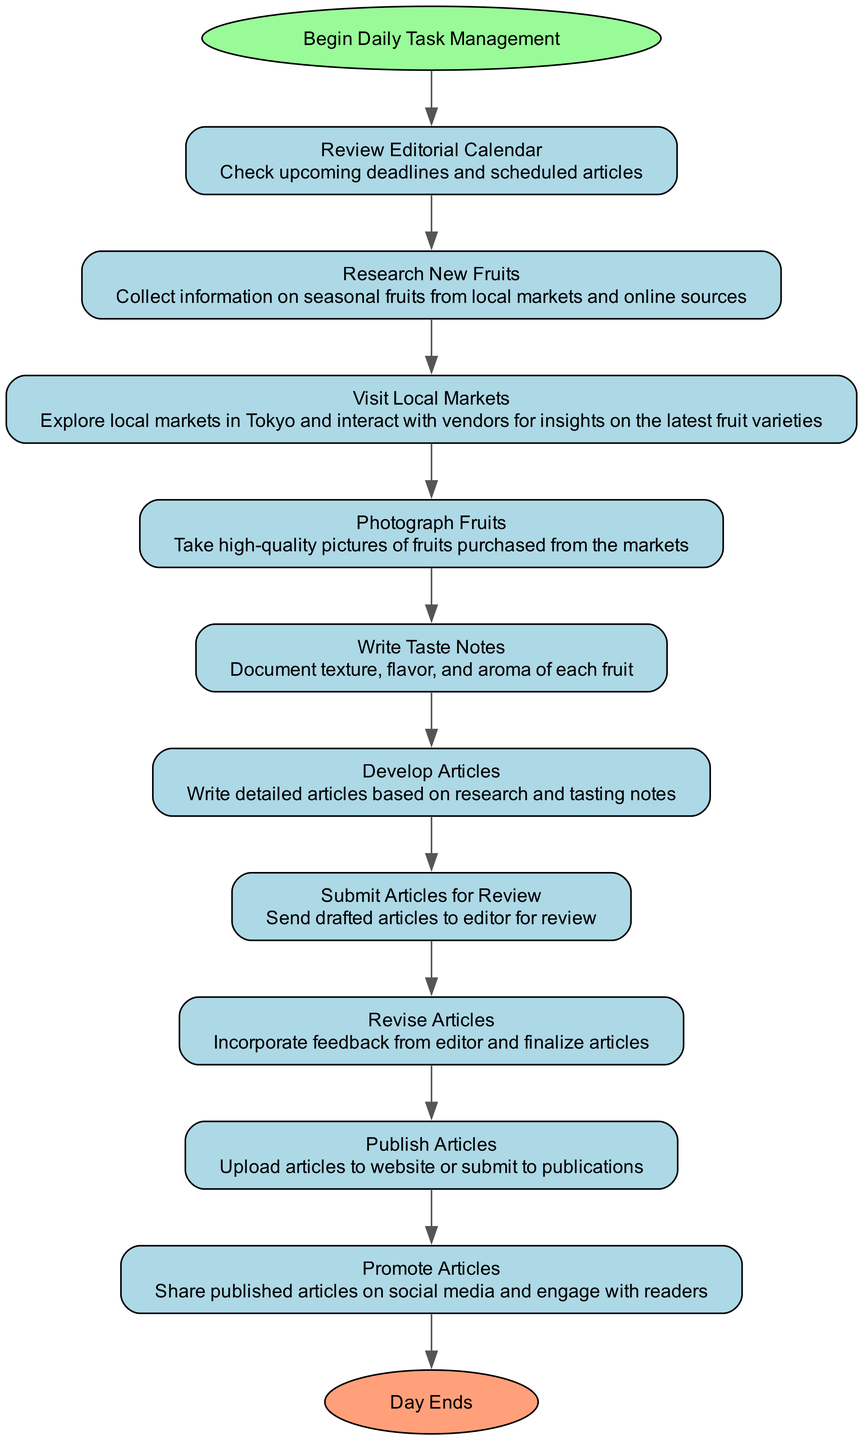What is the first task in the daily management? The first task is found after the "Start" node, which leads to "Review Editorial Calendar". This is the initial action to be taken.
Answer: Review Editorial Calendar How many tasks are listed in the diagram? By counting each task node from "Research New Fruits" to "Promote Articles", we find there are a total of 10 tasks, including "Review Editorial Calendar" and "Promote Articles".
Answer: 10 What is the last task before publishing articles? The task immediately preceding "Publish Articles" is "Revise Articles", as indicated by the arrow flow towards "Publish Articles".
Answer: Revise Articles Which task comes after documenting taste notes? Following "Write Taste Notes", the next task in the flowchart is "Develop Articles". This shows the progression of tasks.
Answer: Develop Articles What is the final output node of the flowchart? The flowchart concludes with the "End" node, which signifies the completion of the daily task management process. This is reached after the last task "Promote Articles".
Answer: Day Ends What is the relationship between "Research New Fruits" and "Visit Local Markets"? "Visit Local Markets" follows "Research New Fruits" directly, indicating that after the research, the next step is to implement the findings by visiting local markets. This shows a sequential dependency.
Answer: Sequential What describes the task of "Promote Articles"? The task of "Promote Articles" involves sharing published articles on social media and engaging with readers, representing the final interaction one has with the crafted content.
Answer: Share published articles How many steps are there from the start to the end of the diagram? There are 10 steps, counting from "Start" to "End", traversing through all tasks included in the process.
Answer: 10 What is the connection between "Submit Articles for Review" and "Revise Articles"? The task "Revise Articles" follows "Submit Articles for Review", indicating that revisions are based on editor feedback received after the articles are submitted.
Answer: Feedback-based revision 